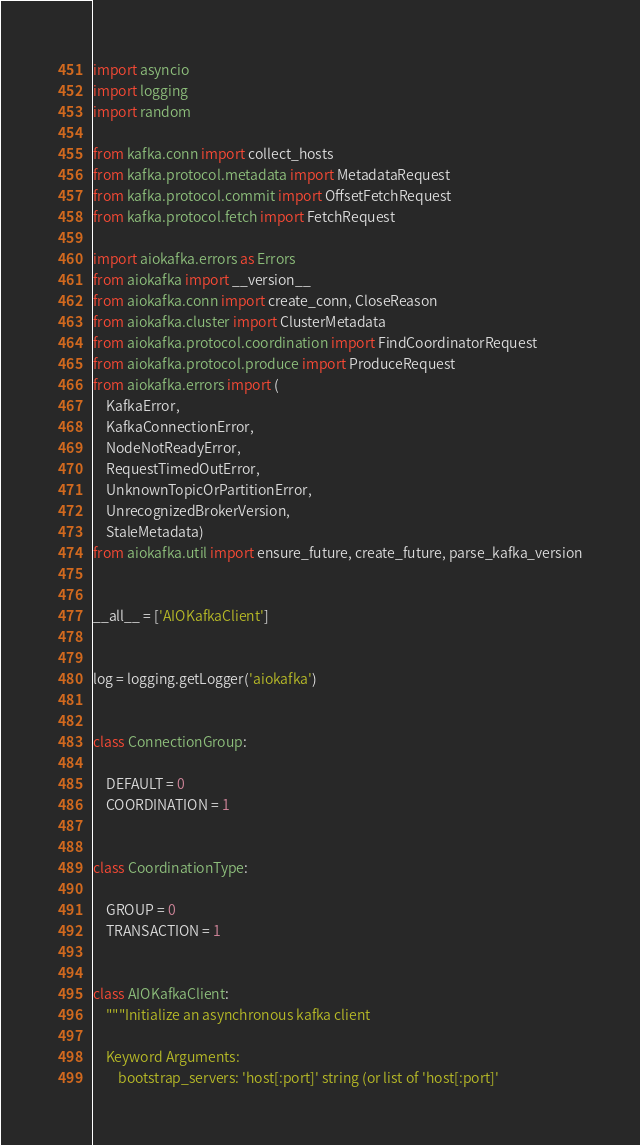<code> <loc_0><loc_0><loc_500><loc_500><_Python_>import asyncio
import logging
import random

from kafka.conn import collect_hosts
from kafka.protocol.metadata import MetadataRequest
from kafka.protocol.commit import OffsetFetchRequest
from kafka.protocol.fetch import FetchRequest

import aiokafka.errors as Errors
from aiokafka import __version__
from aiokafka.conn import create_conn, CloseReason
from aiokafka.cluster import ClusterMetadata
from aiokafka.protocol.coordination import FindCoordinatorRequest
from aiokafka.protocol.produce import ProduceRequest
from aiokafka.errors import (
    KafkaError,
    KafkaConnectionError,
    NodeNotReadyError,
    RequestTimedOutError,
    UnknownTopicOrPartitionError,
    UnrecognizedBrokerVersion,
    StaleMetadata)
from aiokafka.util import ensure_future, create_future, parse_kafka_version


__all__ = ['AIOKafkaClient']


log = logging.getLogger('aiokafka')


class ConnectionGroup:

    DEFAULT = 0
    COORDINATION = 1


class CoordinationType:

    GROUP = 0
    TRANSACTION = 1


class AIOKafkaClient:
    """Initialize an asynchronous kafka client

    Keyword Arguments:
        bootstrap_servers: 'host[:port]' string (or list of 'host[:port]'</code> 